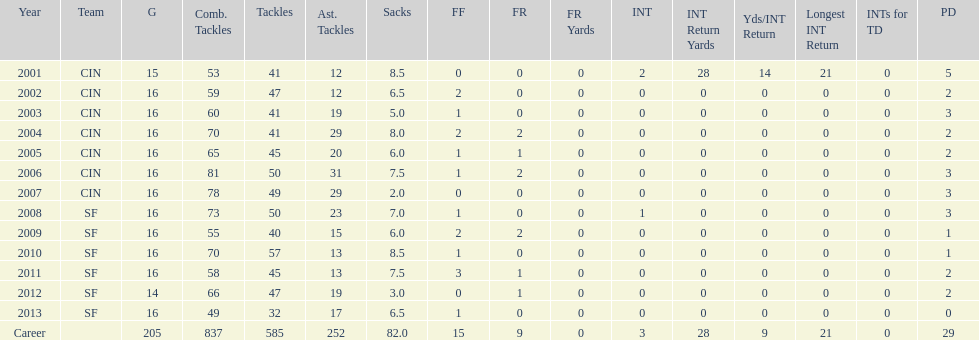What was the number of combined tackles in 2010? 70. 